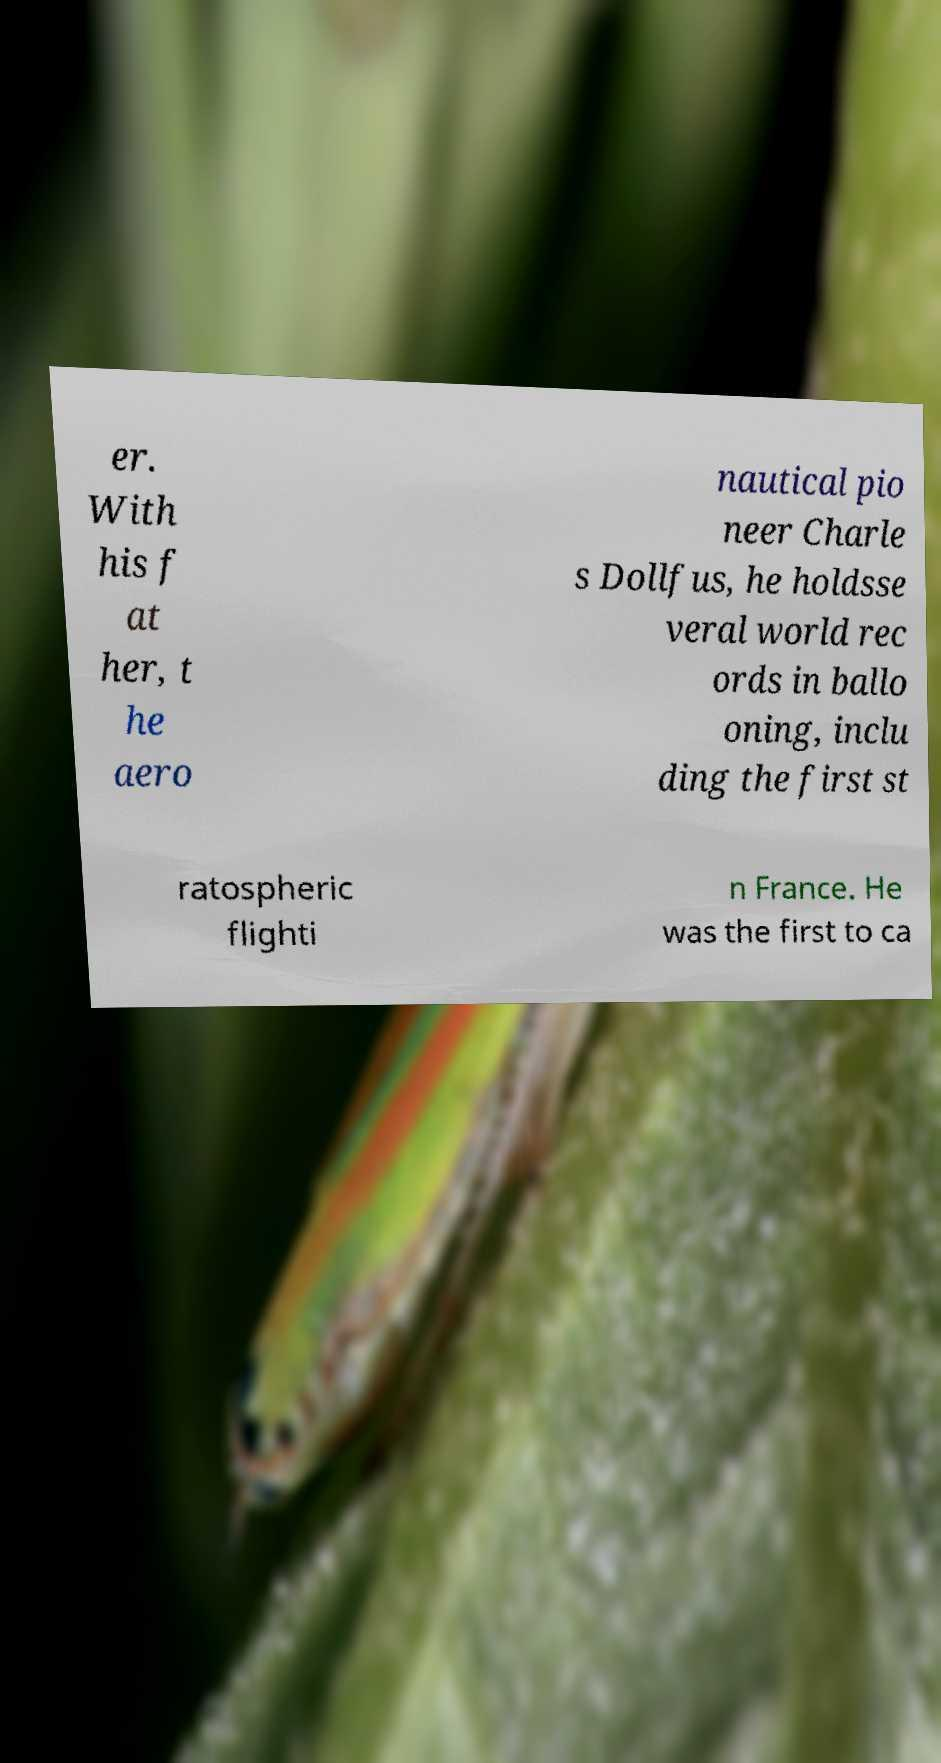Can you accurately transcribe the text from the provided image for me? er. With his f at her, t he aero nautical pio neer Charle s Dollfus, he holdsse veral world rec ords in ballo oning, inclu ding the first st ratospheric flighti n France. He was the first to ca 